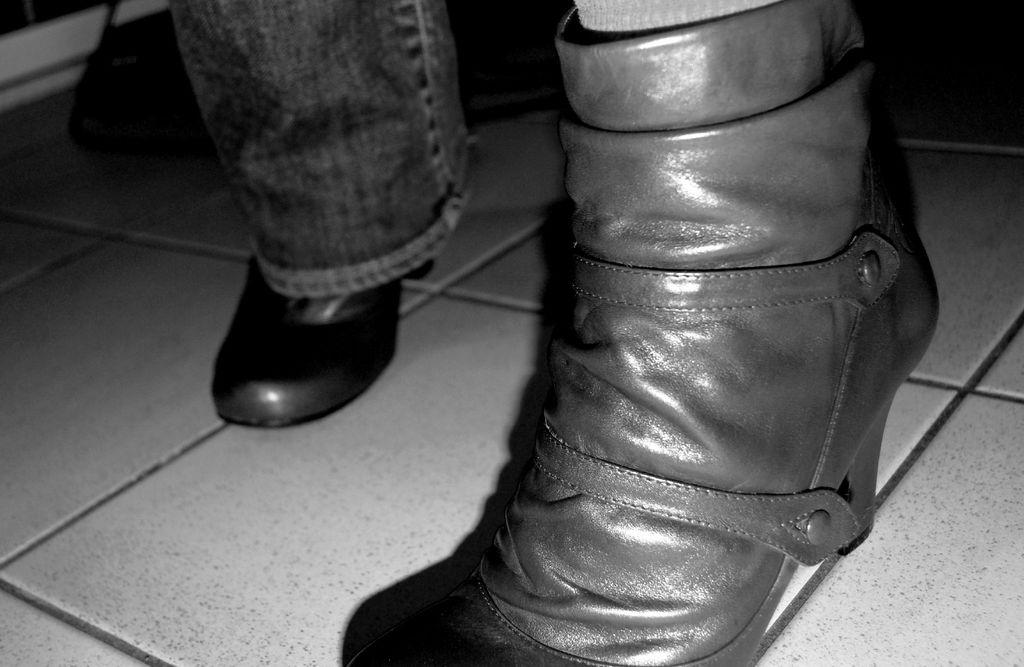What is the color scheme of the image? The image is black and white. What type of clothing can be seen in the image? There are jeans in the image. What type of footwear is on the floor in the image? There are shoes on the floor in the image. What type of jar is visible on the shelf in the image? There is no jar visible in the image; it only features jeans and shoes. How much payment is required to purchase the shoes in the image? There is no information about the price of the shoes in the image. 